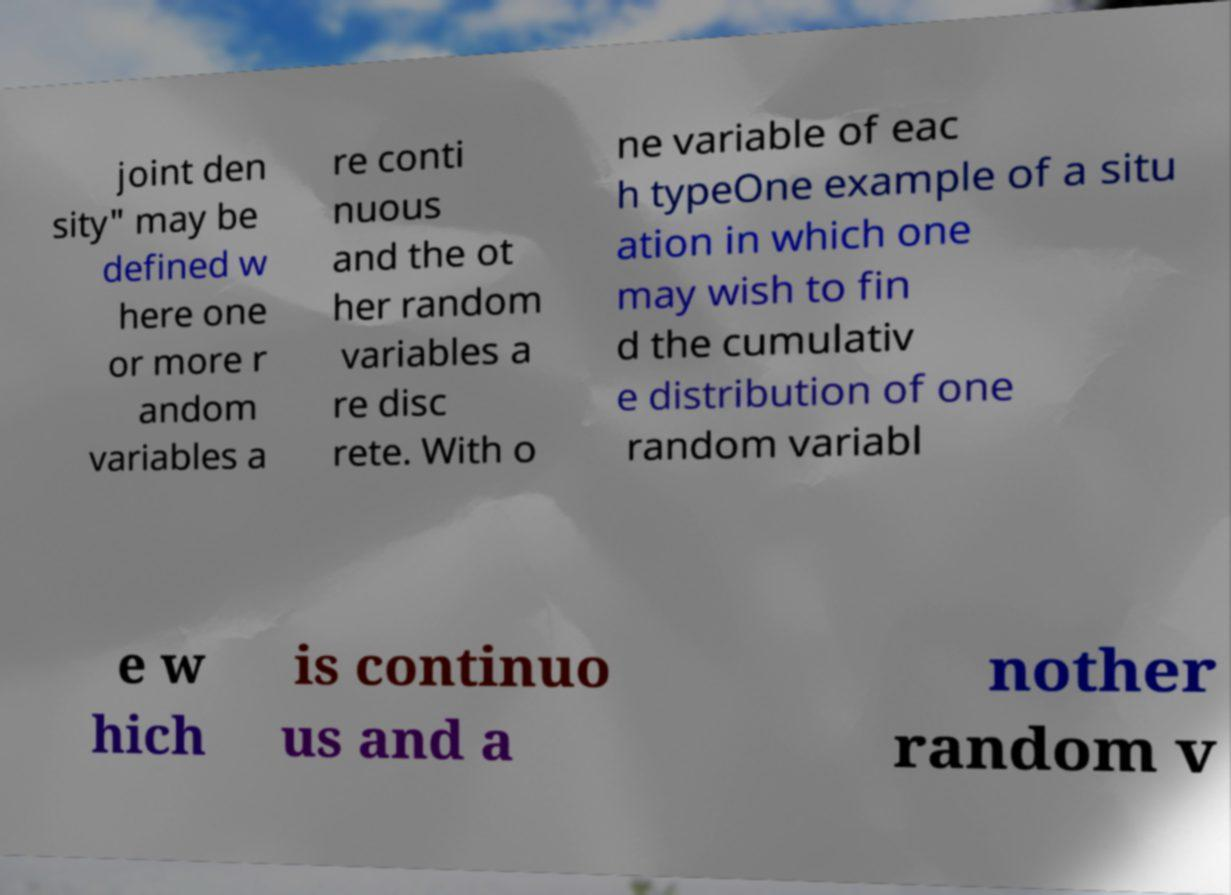Could you assist in decoding the text presented in this image and type it out clearly? joint den sity" may be defined w here one or more r andom variables a re conti nuous and the ot her random variables a re disc rete. With o ne variable of eac h typeOne example of a situ ation in which one may wish to fin d the cumulativ e distribution of one random variabl e w hich is continuo us and a nother random v 